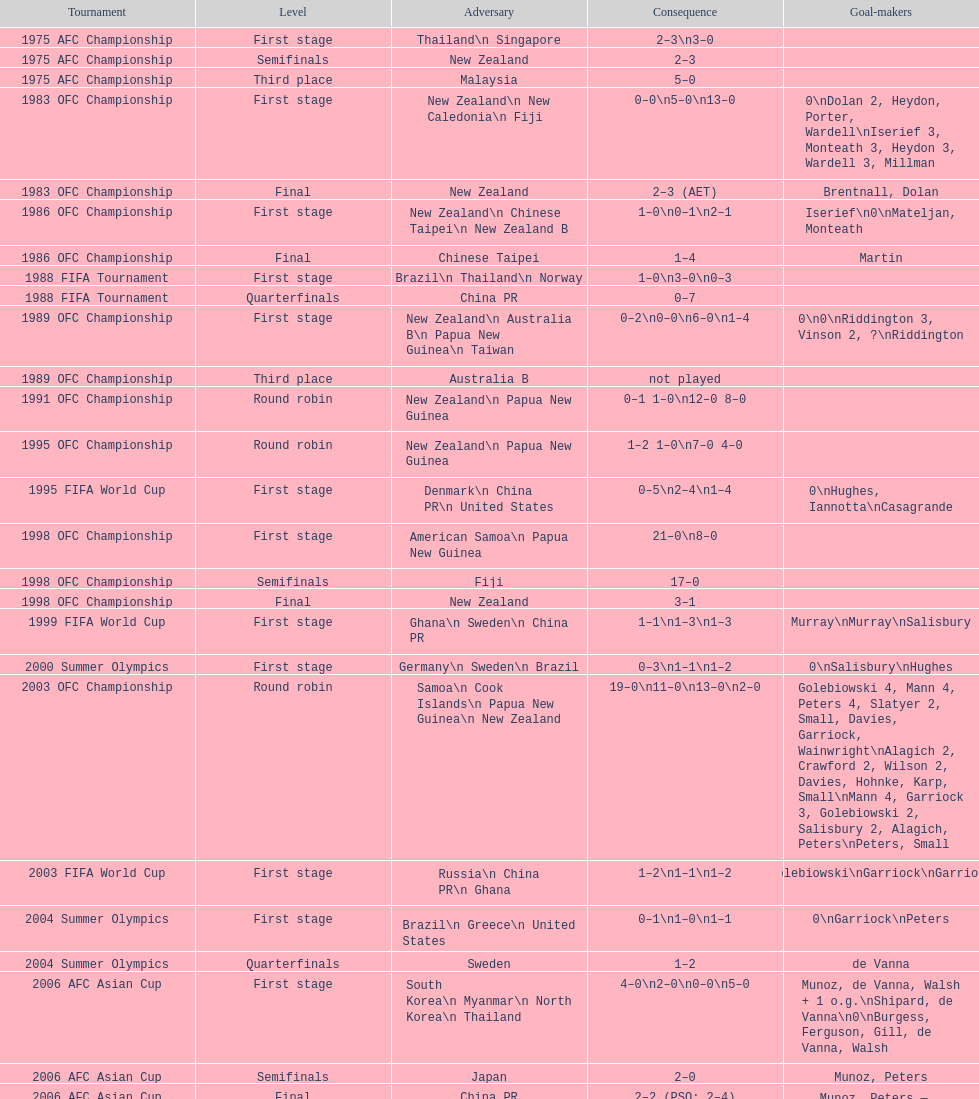During the 1983 ofc championship contest, how many players registered goals? 9. 